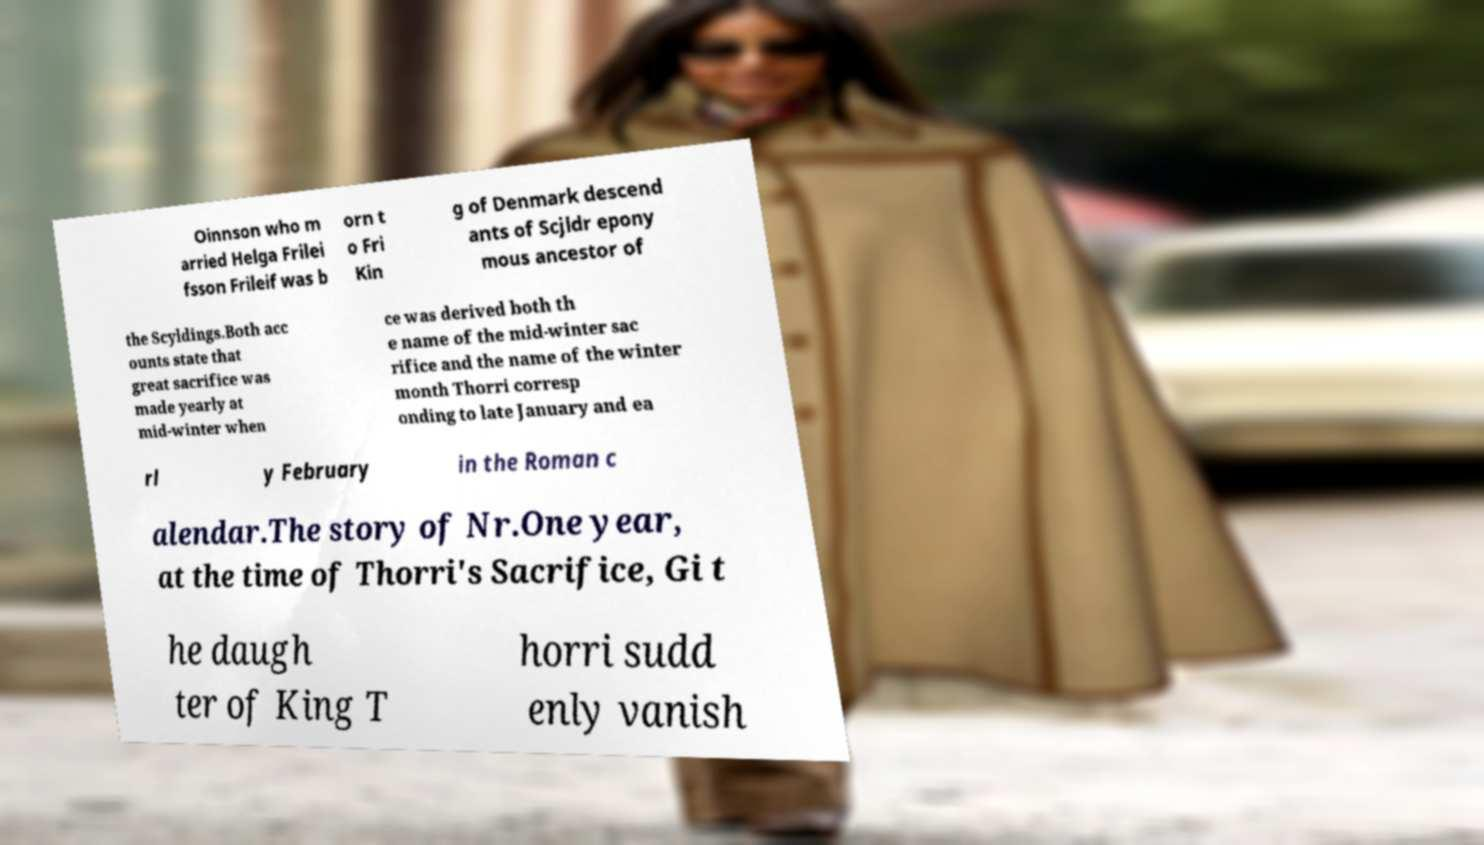What messages or text are displayed in this image? I need them in a readable, typed format. Oinnson who m arried Helga Frilei fsson Frileif was b orn t o Fri Kin g of Denmark descend ants of Scjldr epony mous ancestor of the Scyldings.Both acc ounts state that great sacrifice was made yearly at mid-winter when ce was derived both th e name of the mid-winter sac rifice and the name of the winter month Thorri corresp onding to late January and ea rl y February in the Roman c alendar.The story of Nr.One year, at the time of Thorri's Sacrifice, Gi t he daugh ter of King T horri sudd enly vanish 